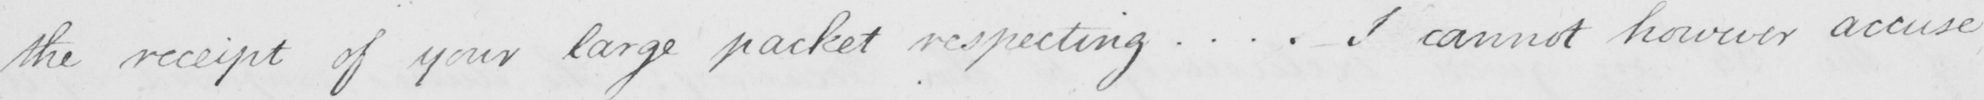What text is written in this handwritten line? the receipt of your large packet respecting ... . I cannot however accuse 